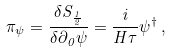<formula> <loc_0><loc_0><loc_500><loc_500>\pi _ { \psi } = \frac { \delta S _ { \frac { 1 } { 2 } } } { \delta \partial _ { 0 } \psi } = \frac { i } { H \tau } \psi ^ { \dag } \, ,</formula> 